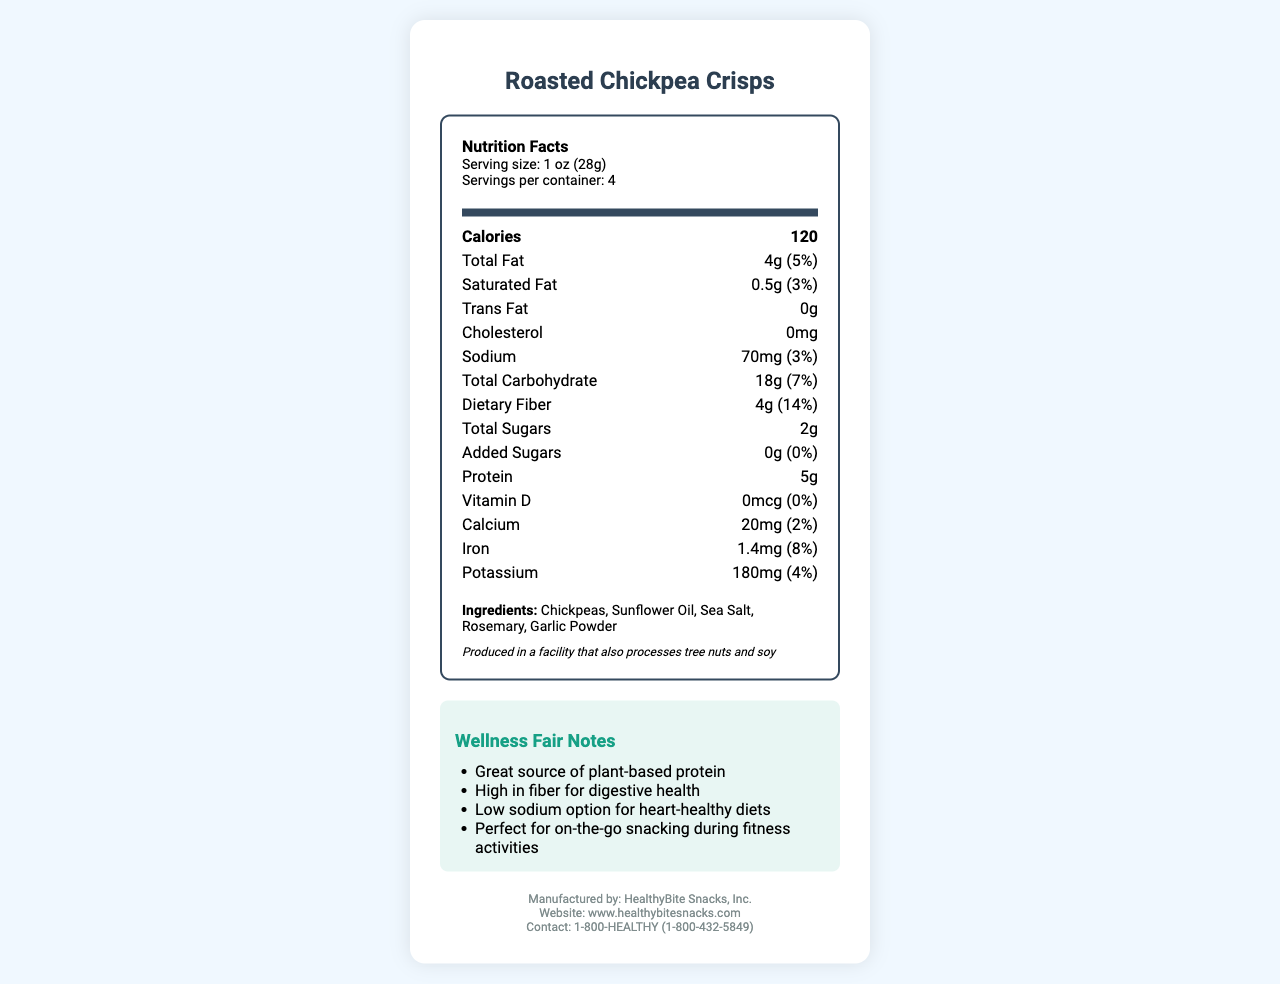what is the serving size for Roasted Chickpea Crisps? The serving size information is specified under the "Nutrition Facts" section, indicating "Serving size: 1 oz (28g)".
Answer: 1 oz (28g) how many calories are in one serving of Roasted Chickpea Crisps? The calorie count is bolded and prominently displayed in the "Nutrition Facts" section.
Answer: 120 what percentage of the Daily Value for sodium does one serving provide? In the "Nutrition Facts" section, the sodium content is listed with a percentage of the daily value, which is 3%.
Answer: 3% what allergens are mentioned on the label? The allergen information is provided in italics towards the bottom under the ingredients, stating "Produced in a facility that also processes tree nuts and soy".
Answer: Tree nuts and soy how much protein is in a serving of these crisps? The amount of protein listed per serving is given in the "Nutrition Facts" section as 5g.
Answer: 5g does the product contain any added sugars? A. Yes B. No The "Nutrition Facts" section shows "Added Sugars" with an amount of 0g and a daily value of 0%, indicating that there are no added sugars.
Answer: B which of the following ingredients is NOT in Roasted Chickpea Crisps? A. Chickpeas B. Corn Oil C. Sea Salt D. Rosemary The ingredient list under the "Ingredients" section does not include corn oil, but it does list chickpeas, sea salt, and rosemary.
Answer: B is Roasted Chickpea Crisps suitable for vegans? The document has a clear label stating that the product is vegan, found in the wellness notes section.
Answer: Yes summarize the main health benefits of Roasted Chickpea Crisps listed on the document. The "Wellness Fair Notes" section highlights these key benefits among the bullet points.
Answer: Great source of plant-based protein, High in fiber for digestive health, Low sodium option for heart-healthy diets, Perfect for on-the-go snacking during fitness activities who manufactures Roasted Chickpea Crisps? The contact information at the bottom of the document lists the manufacturer as HealthyBite Snacks, Inc.
Answer: HealthyBite Snacks, Inc. what is the total fiber content per serving, and why is this important for health? The dietary fiber content listed in the "Nutrition Facts" section is 4g, which is significant as it helps with digestive health.
Answer: 4g how many servings are there in one container of Roasted Chickpea Crisps? The serving information specifies "Servings per container: 4".
Answer: 4 what percentage of the Daily Value of Vitamin D does the product provide? The "Nutrition Facts" section indicates that there is 0mcg of Vitamin D, which is 0% of the daily value.
Answer: 0% does the document state that the product is non-GMO? The wellness notes section clearly states the product is non-GMO.
Answer: Yes can the exact production location of the Roasted Chickpea Crisps be determined from this document? The document provides the manufacturer's name and contact information but does not give a specific address for the production location.
Answer: Not enough information 